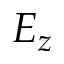<formula> <loc_0><loc_0><loc_500><loc_500>E _ { z }</formula> 